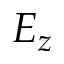<formula> <loc_0><loc_0><loc_500><loc_500>E _ { z }</formula> 